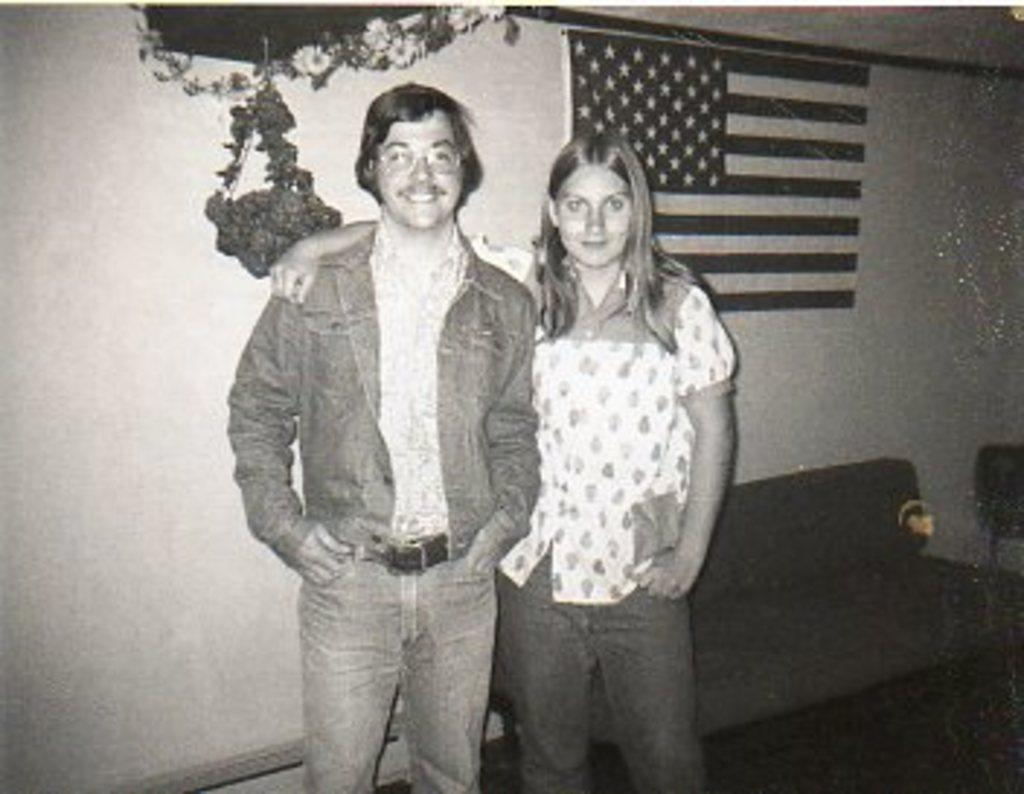What is the color scheme of the image? The image is black and white. What can be seen in the image involving people? There is a couple standing in the image. What furniture is present on the right side of the image? There is a couch and a chair on the right side of the image. What is located at the top of the image? There is a flag at the top of the image. What decorative item is on the left side of the image? There is a garland on the left side of the image. What sense is being stimulated by the image? The image is black and white, so it primarily stimulates the sense of sight. However, the image itself does not directly stimulate other senses like taste, touch, smell, or hearing. 